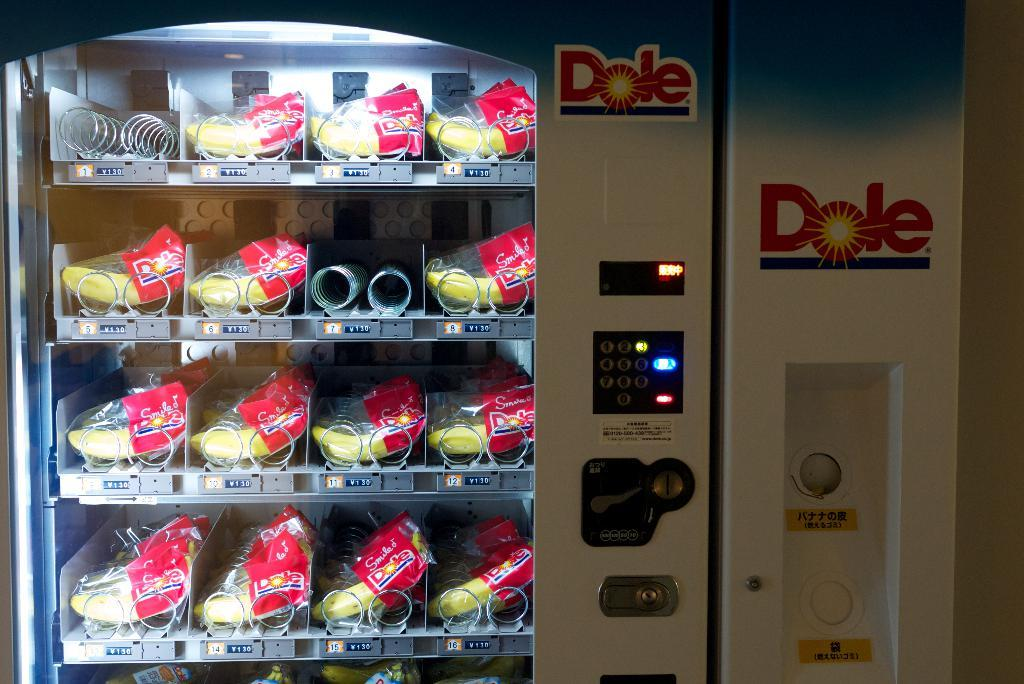Provide a one-sentence caption for the provided image. A Dole fruit vending machine with bananas inside the machine. 